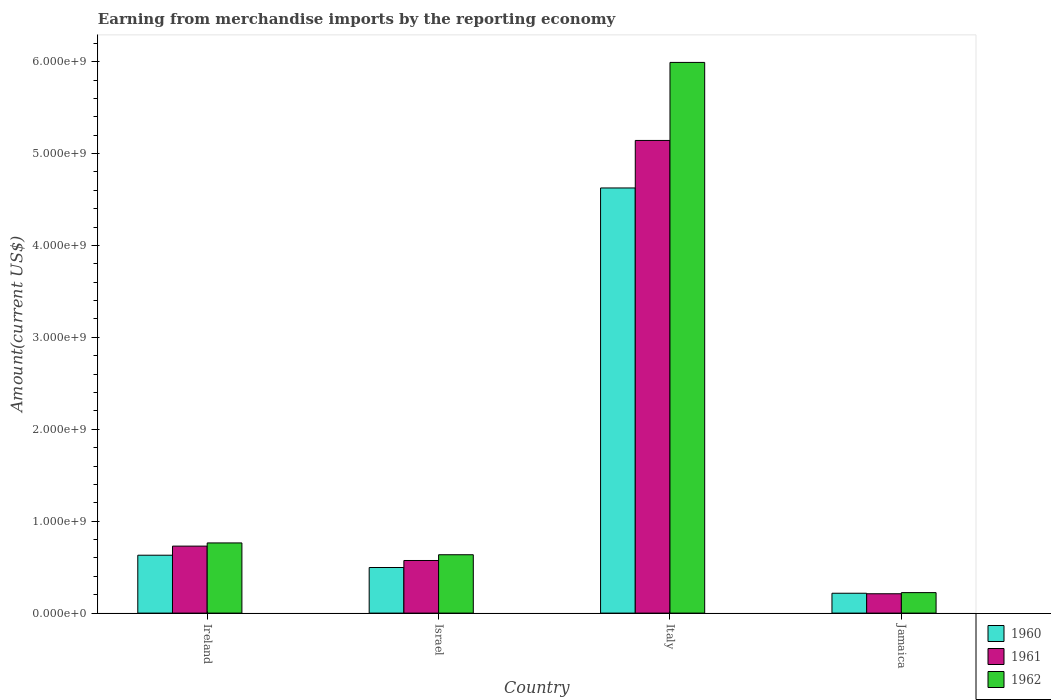How many different coloured bars are there?
Give a very brief answer. 3. How many groups of bars are there?
Your answer should be compact. 4. Are the number of bars per tick equal to the number of legend labels?
Keep it short and to the point. Yes. Are the number of bars on each tick of the X-axis equal?
Provide a succinct answer. Yes. How many bars are there on the 1st tick from the left?
Your response must be concise. 3. What is the label of the 1st group of bars from the left?
Keep it short and to the point. Ireland. In how many cases, is the number of bars for a given country not equal to the number of legend labels?
Offer a terse response. 0. What is the amount earned from merchandise imports in 1961 in Jamaica?
Offer a terse response. 2.10e+08. Across all countries, what is the maximum amount earned from merchandise imports in 1962?
Offer a very short reply. 5.99e+09. Across all countries, what is the minimum amount earned from merchandise imports in 1962?
Give a very brief answer. 2.23e+08. In which country was the amount earned from merchandise imports in 1961 minimum?
Offer a terse response. Jamaica. What is the total amount earned from merchandise imports in 1962 in the graph?
Your answer should be very brief. 7.61e+09. What is the difference between the amount earned from merchandise imports in 1962 in Israel and that in Jamaica?
Ensure brevity in your answer.  4.12e+08. What is the difference between the amount earned from merchandise imports in 1960 in Ireland and the amount earned from merchandise imports in 1961 in Jamaica?
Keep it short and to the point. 4.20e+08. What is the average amount earned from merchandise imports in 1962 per country?
Your answer should be compact. 1.90e+09. What is the difference between the amount earned from merchandise imports of/in 1961 and amount earned from merchandise imports of/in 1962 in Italy?
Keep it short and to the point. -8.49e+08. What is the ratio of the amount earned from merchandise imports in 1962 in Israel to that in Jamaica?
Give a very brief answer. 2.85. Is the amount earned from merchandise imports in 1960 in Italy less than that in Jamaica?
Give a very brief answer. No. What is the difference between the highest and the second highest amount earned from merchandise imports in 1960?
Offer a terse response. 4.00e+09. What is the difference between the highest and the lowest amount earned from merchandise imports in 1960?
Provide a succinct answer. 4.41e+09. What does the 3rd bar from the right in Israel represents?
Give a very brief answer. 1960. How many bars are there?
Your answer should be compact. 12. Are all the bars in the graph horizontal?
Ensure brevity in your answer.  No. How many countries are there in the graph?
Your answer should be compact. 4. What is the difference between two consecutive major ticks on the Y-axis?
Your response must be concise. 1.00e+09. Are the values on the major ticks of Y-axis written in scientific E-notation?
Ensure brevity in your answer.  Yes. Where does the legend appear in the graph?
Your response must be concise. Bottom right. What is the title of the graph?
Keep it short and to the point. Earning from merchandise imports by the reporting economy. Does "2004" appear as one of the legend labels in the graph?
Make the answer very short. No. What is the label or title of the Y-axis?
Your response must be concise. Amount(current US$). What is the Amount(current US$) of 1960 in Ireland?
Your response must be concise. 6.30e+08. What is the Amount(current US$) of 1961 in Ireland?
Keep it short and to the point. 7.29e+08. What is the Amount(current US$) of 1962 in Ireland?
Your answer should be compact. 7.64e+08. What is the Amount(current US$) in 1960 in Israel?
Offer a terse response. 4.96e+08. What is the Amount(current US$) in 1961 in Israel?
Ensure brevity in your answer.  5.72e+08. What is the Amount(current US$) of 1962 in Israel?
Ensure brevity in your answer.  6.35e+08. What is the Amount(current US$) in 1960 in Italy?
Offer a very short reply. 4.63e+09. What is the Amount(current US$) in 1961 in Italy?
Your answer should be very brief. 5.14e+09. What is the Amount(current US$) of 1962 in Italy?
Ensure brevity in your answer.  5.99e+09. What is the Amount(current US$) of 1960 in Jamaica?
Provide a short and direct response. 2.16e+08. What is the Amount(current US$) of 1961 in Jamaica?
Your answer should be very brief. 2.10e+08. What is the Amount(current US$) of 1962 in Jamaica?
Give a very brief answer. 2.23e+08. Across all countries, what is the maximum Amount(current US$) of 1960?
Offer a terse response. 4.63e+09. Across all countries, what is the maximum Amount(current US$) of 1961?
Your answer should be compact. 5.14e+09. Across all countries, what is the maximum Amount(current US$) of 1962?
Ensure brevity in your answer.  5.99e+09. Across all countries, what is the minimum Amount(current US$) of 1960?
Your answer should be compact. 2.16e+08. Across all countries, what is the minimum Amount(current US$) in 1961?
Provide a short and direct response. 2.10e+08. Across all countries, what is the minimum Amount(current US$) in 1962?
Make the answer very short. 2.23e+08. What is the total Amount(current US$) of 1960 in the graph?
Keep it short and to the point. 5.97e+09. What is the total Amount(current US$) of 1961 in the graph?
Your answer should be very brief. 6.65e+09. What is the total Amount(current US$) in 1962 in the graph?
Give a very brief answer. 7.61e+09. What is the difference between the Amount(current US$) in 1960 in Ireland and that in Israel?
Ensure brevity in your answer.  1.34e+08. What is the difference between the Amount(current US$) of 1961 in Ireland and that in Israel?
Offer a terse response. 1.56e+08. What is the difference between the Amount(current US$) of 1962 in Ireland and that in Israel?
Keep it short and to the point. 1.29e+08. What is the difference between the Amount(current US$) of 1960 in Ireland and that in Italy?
Your answer should be compact. -4.00e+09. What is the difference between the Amount(current US$) in 1961 in Ireland and that in Italy?
Keep it short and to the point. -4.41e+09. What is the difference between the Amount(current US$) in 1962 in Ireland and that in Italy?
Your answer should be very brief. -5.23e+09. What is the difference between the Amount(current US$) of 1960 in Ireland and that in Jamaica?
Provide a short and direct response. 4.14e+08. What is the difference between the Amount(current US$) of 1961 in Ireland and that in Jamaica?
Provide a succinct answer. 5.18e+08. What is the difference between the Amount(current US$) in 1962 in Ireland and that in Jamaica?
Your answer should be compact. 5.41e+08. What is the difference between the Amount(current US$) in 1960 in Israel and that in Italy?
Make the answer very short. -4.13e+09. What is the difference between the Amount(current US$) in 1961 in Israel and that in Italy?
Your answer should be very brief. -4.57e+09. What is the difference between the Amount(current US$) in 1962 in Israel and that in Italy?
Your answer should be compact. -5.36e+09. What is the difference between the Amount(current US$) in 1960 in Israel and that in Jamaica?
Offer a terse response. 2.80e+08. What is the difference between the Amount(current US$) in 1961 in Israel and that in Jamaica?
Provide a succinct answer. 3.62e+08. What is the difference between the Amount(current US$) in 1962 in Israel and that in Jamaica?
Provide a short and direct response. 4.12e+08. What is the difference between the Amount(current US$) of 1960 in Italy and that in Jamaica?
Give a very brief answer. 4.41e+09. What is the difference between the Amount(current US$) of 1961 in Italy and that in Jamaica?
Make the answer very short. 4.93e+09. What is the difference between the Amount(current US$) in 1962 in Italy and that in Jamaica?
Offer a very short reply. 5.77e+09. What is the difference between the Amount(current US$) in 1960 in Ireland and the Amount(current US$) in 1961 in Israel?
Your response must be concise. 5.76e+07. What is the difference between the Amount(current US$) in 1960 in Ireland and the Amount(current US$) in 1962 in Israel?
Give a very brief answer. -5.00e+06. What is the difference between the Amount(current US$) of 1961 in Ireland and the Amount(current US$) of 1962 in Israel?
Provide a succinct answer. 9.39e+07. What is the difference between the Amount(current US$) of 1960 in Ireland and the Amount(current US$) of 1961 in Italy?
Provide a succinct answer. -4.51e+09. What is the difference between the Amount(current US$) of 1960 in Ireland and the Amount(current US$) of 1962 in Italy?
Provide a succinct answer. -5.36e+09. What is the difference between the Amount(current US$) in 1961 in Ireland and the Amount(current US$) in 1962 in Italy?
Offer a very short reply. -5.26e+09. What is the difference between the Amount(current US$) of 1960 in Ireland and the Amount(current US$) of 1961 in Jamaica?
Ensure brevity in your answer.  4.20e+08. What is the difference between the Amount(current US$) in 1960 in Ireland and the Amount(current US$) in 1962 in Jamaica?
Your answer should be compact. 4.07e+08. What is the difference between the Amount(current US$) of 1961 in Ireland and the Amount(current US$) of 1962 in Jamaica?
Ensure brevity in your answer.  5.06e+08. What is the difference between the Amount(current US$) in 1960 in Israel and the Amount(current US$) in 1961 in Italy?
Make the answer very short. -4.65e+09. What is the difference between the Amount(current US$) in 1960 in Israel and the Amount(current US$) in 1962 in Italy?
Make the answer very short. -5.50e+09. What is the difference between the Amount(current US$) of 1961 in Israel and the Amount(current US$) of 1962 in Italy?
Make the answer very short. -5.42e+09. What is the difference between the Amount(current US$) of 1960 in Israel and the Amount(current US$) of 1961 in Jamaica?
Your answer should be compact. 2.86e+08. What is the difference between the Amount(current US$) of 1960 in Israel and the Amount(current US$) of 1962 in Jamaica?
Provide a succinct answer. 2.73e+08. What is the difference between the Amount(current US$) of 1961 in Israel and the Amount(current US$) of 1962 in Jamaica?
Provide a succinct answer. 3.49e+08. What is the difference between the Amount(current US$) of 1960 in Italy and the Amount(current US$) of 1961 in Jamaica?
Offer a very short reply. 4.42e+09. What is the difference between the Amount(current US$) in 1960 in Italy and the Amount(current US$) in 1962 in Jamaica?
Your answer should be very brief. 4.40e+09. What is the difference between the Amount(current US$) in 1961 in Italy and the Amount(current US$) in 1962 in Jamaica?
Your answer should be very brief. 4.92e+09. What is the average Amount(current US$) in 1960 per country?
Offer a terse response. 1.49e+09. What is the average Amount(current US$) of 1961 per country?
Provide a short and direct response. 1.66e+09. What is the average Amount(current US$) of 1962 per country?
Give a very brief answer. 1.90e+09. What is the difference between the Amount(current US$) of 1960 and Amount(current US$) of 1961 in Ireland?
Your answer should be compact. -9.89e+07. What is the difference between the Amount(current US$) of 1960 and Amount(current US$) of 1962 in Ireland?
Provide a short and direct response. -1.34e+08. What is the difference between the Amount(current US$) of 1961 and Amount(current US$) of 1962 in Ireland?
Offer a terse response. -3.47e+07. What is the difference between the Amount(current US$) of 1960 and Amount(current US$) of 1961 in Israel?
Ensure brevity in your answer.  -7.62e+07. What is the difference between the Amount(current US$) of 1960 and Amount(current US$) of 1962 in Israel?
Ensure brevity in your answer.  -1.39e+08. What is the difference between the Amount(current US$) of 1961 and Amount(current US$) of 1962 in Israel?
Keep it short and to the point. -6.26e+07. What is the difference between the Amount(current US$) of 1960 and Amount(current US$) of 1961 in Italy?
Give a very brief answer. -5.17e+08. What is the difference between the Amount(current US$) in 1960 and Amount(current US$) in 1962 in Italy?
Your answer should be compact. -1.37e+09. What is the difference between the Amount(current US$) of 1961 and Amount(current US$) of 1962 in Italy?
Keep it short and to the point. -8.49e+08. What is the difference between the Amount(current US$) in 1960 and Amount(current US$) in 1961 in Jamaica?
Provide a succinct answer. 5.70e+06. What is the difference between the Amount(current US$) of 1960 and Amount(current US$) of 1962 in Jamaica?
Your answer should be very brief. -6.80e+06. What is the difference between the Amount(current US$) of 1961 and Amount(current US$) of 1962 in Jamaica?
Your answer should be compact. -1.25e+07. What is the ratio of the Amount(current US$) of 1960 in Ireland to that in Israel?
Keep it short and to the point. 1.27. What is the ratio of the Amount(current US$) in 1961 in Ireland to that in Israel?
Make the answer very short. 1.27. What is the ratio of the Amount(current US$) of 1962 in Ireland to that in Israel?
Your answer should be very brief. 1.2. What is the ratio of the Amount(current US$) of 1960 in Ireland to that in Italy?
Your answer should be compact. 0.14. What is the ratio of the Amount(current US$) in 1961 in Ireland to that in Italy?
Ensure brevity in your answer.  0.14. What is the ratio of the Amount(current US$) in 1962 in Ireland to that in Italy?
Provide a succinct answer. 0.13. What is the ratio of the Amount(current US$) in 1960 in Ireland to that in Jamaica?
Your response must be concise. 2.91. What is the ratio of the Amount(current US$) in 1961 in Ireland to that in Jamaica?
Offer a terse response. 3.46. What is the ratio of the Amount(current US$) in 1962 in Ireland to that in Jamaica?
Make the answer very short. 3.43. What is the ratio of the Amount(current US$) of 1960 in Israel to that in Italy?
Ensure brevity in your answer.  0.11. What is the ratio of the Amount(current US$) of 1961 in Israel to that in Italy?
Your response must be concise. 0.11. What is the ratio of the Amount(current US$) in 1962 in Israel to that in Italy?
Your response must be concise. 0.11. What is the ratio of the Amount(current US$) in 1960 in Israel to that in Jamaica?
Give a very brief answer. 2.3. What is the ratio of the Amount(current US$) in 1961 in Israel to that in Jamaica?
Provide a succinct answer. 2.72. What is the ratio of the Amount(current US$) of 1962 in Israel to that in Jamaica?
Offer a terse response. 2.85. What is the ratio of the Amount(current US$) of 1960 in Italy to that in Jamaica?
Offer a very short reply. 21.4. What is the ratio of the Amount(current US$) in 1961 in Italy to that in Jamaica?
Ensure brevity in your answer.  24.44. What is the ratio of the Amount(current US$) in 1962 in Italy to that in Jamaica?
Keep it short and to the point. 26.88. What is the difference between the highest and the second highest Amount(current US$) in 1960?
Ensure brevity in your answer.  4.00e+09. What is the difference between the highest and the second highest Amount(current US$) in 1961?
Your answer should be compact. 4.41e+09. What is the difference between the highest and the second highest Amount(current US$) in 1962?
Give a very brief answer. 5.23e+09. What is the difference between the highest and the lowest Amount(current US$) in 1960?
Give a very brief answer. 4.41e+09. What is the difference between the highest and the lowest Amount(current US$) of 1961?
Provide a succinct answer. 4.93e+09. What is the difference between the highest and the lowest Amount(current US$) of 1962?
Your answer should be compact. 5.77e+09. 